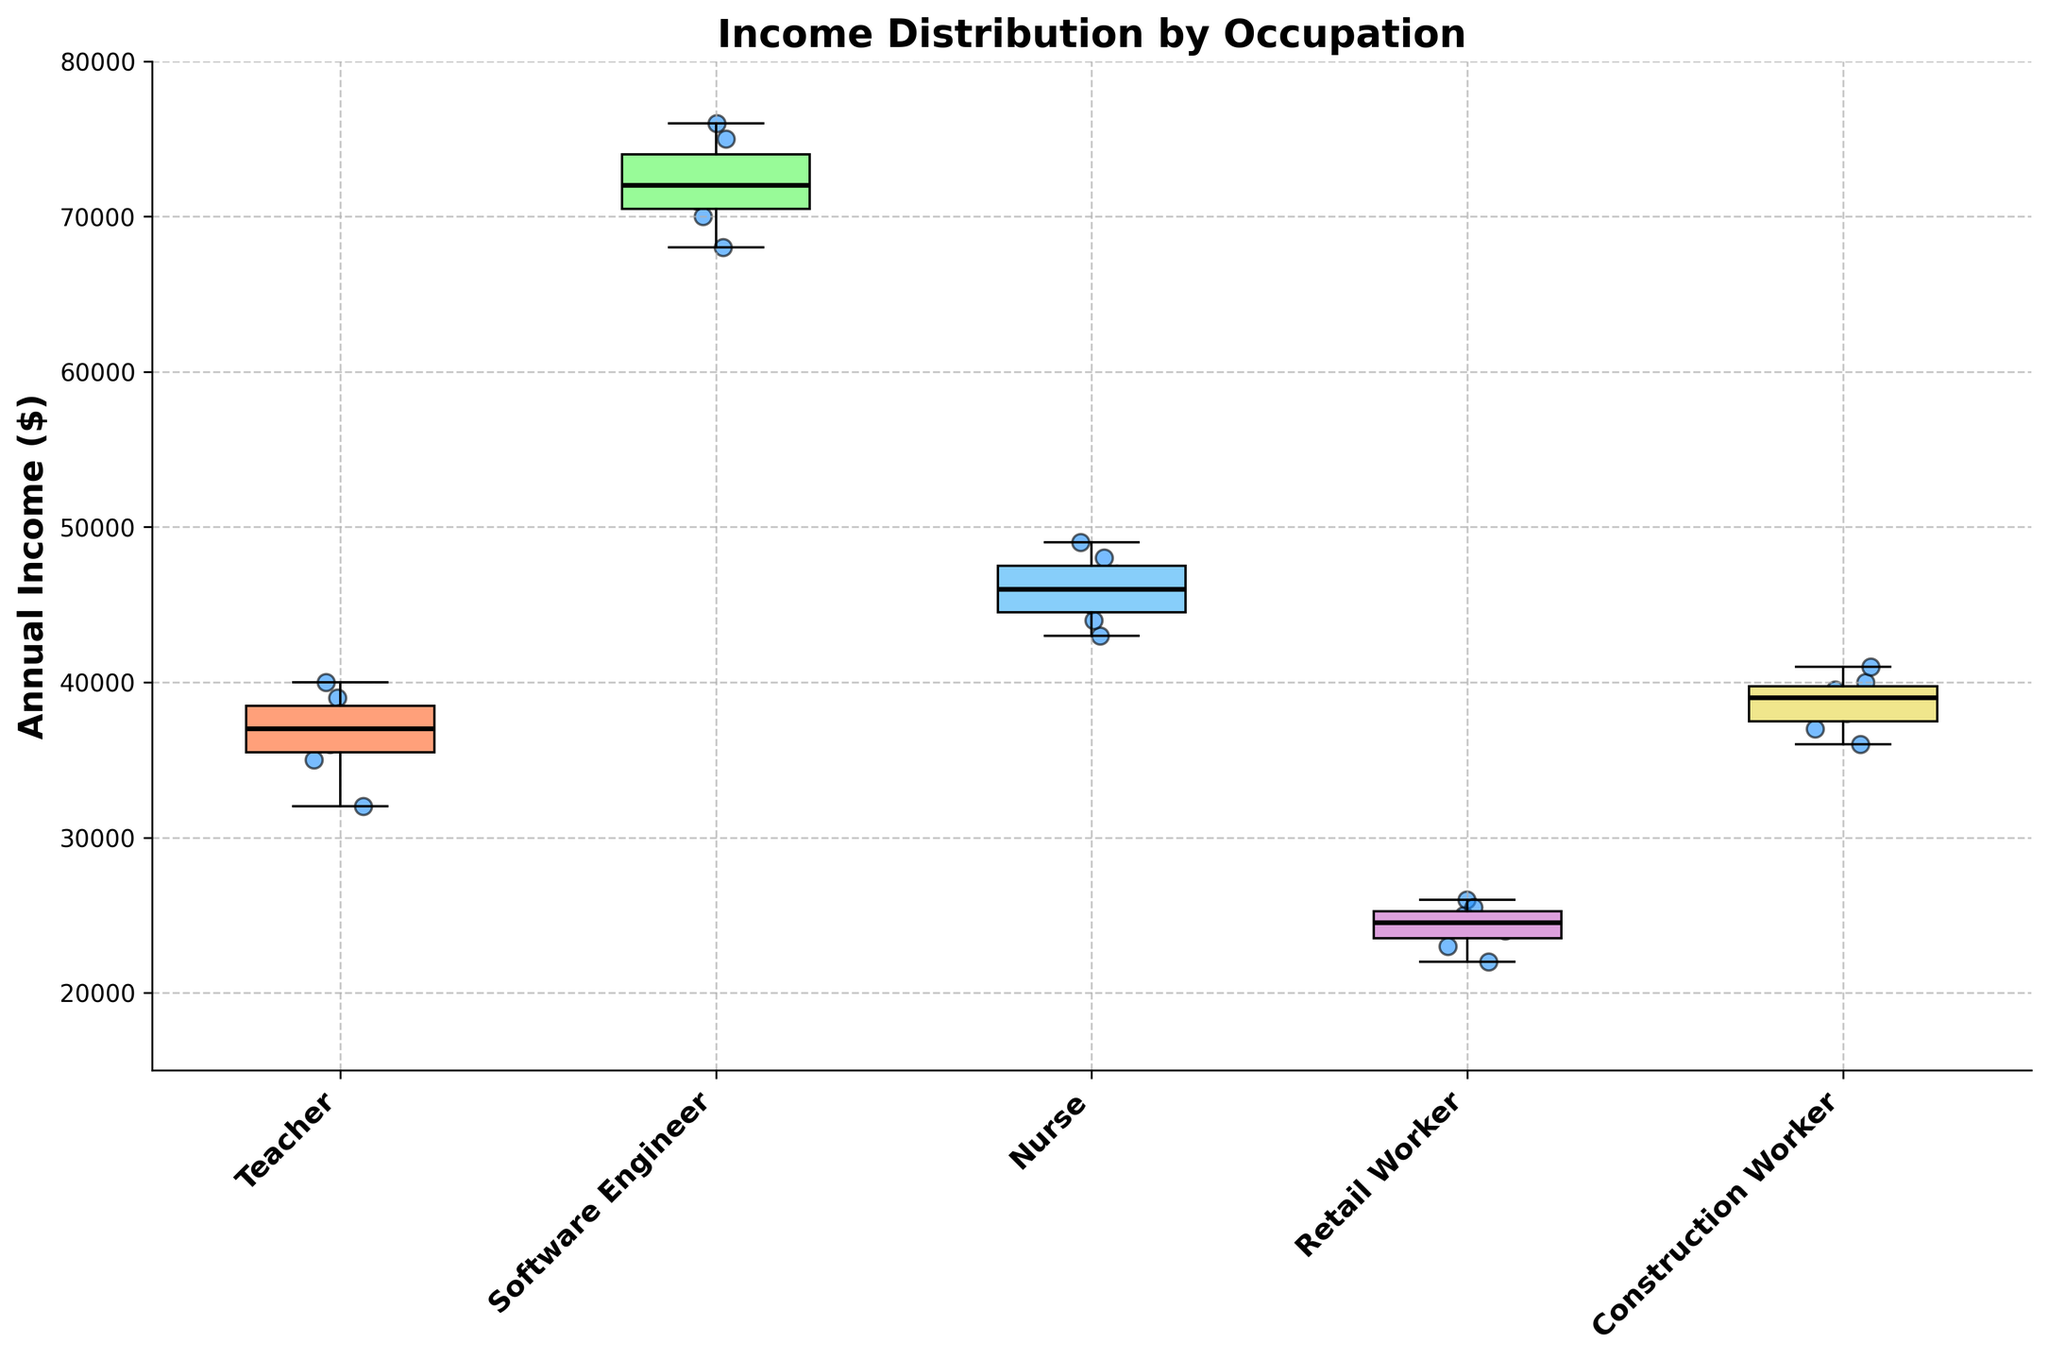What is the title of the figure? The title of the figure is displayed at the top and reads "Income Distribution by Occupation".
Answer: Income Distribution by Occupation What is the range of incomes shown on the y-axis? The range of incomes shown on the y-axis is indicated by the labels running vertically and spans from 15,000 to 80,000 dollars.
Answer: 15,000 to 80,000 Which occupation has the highest median income? The median income for each occupation is represented by the black line within each box. The occupation with the highest median income is the Software Engineer.
Answer: Software Engineer How does the median income of Retail Workers compare to that of Teachers? The median income is represented by the black line. The median for Retail Workers is lower than that of Teachers.
Answer: Lower Which occupation group shows the widest range of incomes? The range of incomes is indicated by the length of the boxes and whiskers. The Software Engineer group has the widest income range.
Answer: Software Engineer What is the interquartile range (IQR) of income for Nurses? The IQR is the range between the first quartile (Q1) and the third quartile (Q3). This is represented by the box's edges for the Nurse category. It spans from approximately 44,000 to 48,000 dollars, so the IQR is about 4,000 dollars.
Answer: 4,000 Do any occupations have outliers? If so, which ones? Outliers are represented by red diamonds outside the whiskers. The figure does not show any outliers for any occupation.
Answer: None What is the primary color of the box plot representing Construction Workers? The primary color of the box plot for Construction Workers can be observed from the colored boxes. It is #F0E68C (a shade of yellow).
Answer: Yellow By approximately how much does the highest income for Software Engineers exceed that of Teachers? The highest income for Software Engineers is around 76,000, while for Teachers, it is around 40,000. Calculate the difference: 76,000 - 40,000 = 36,000 dollars.
Answer: 36,000 